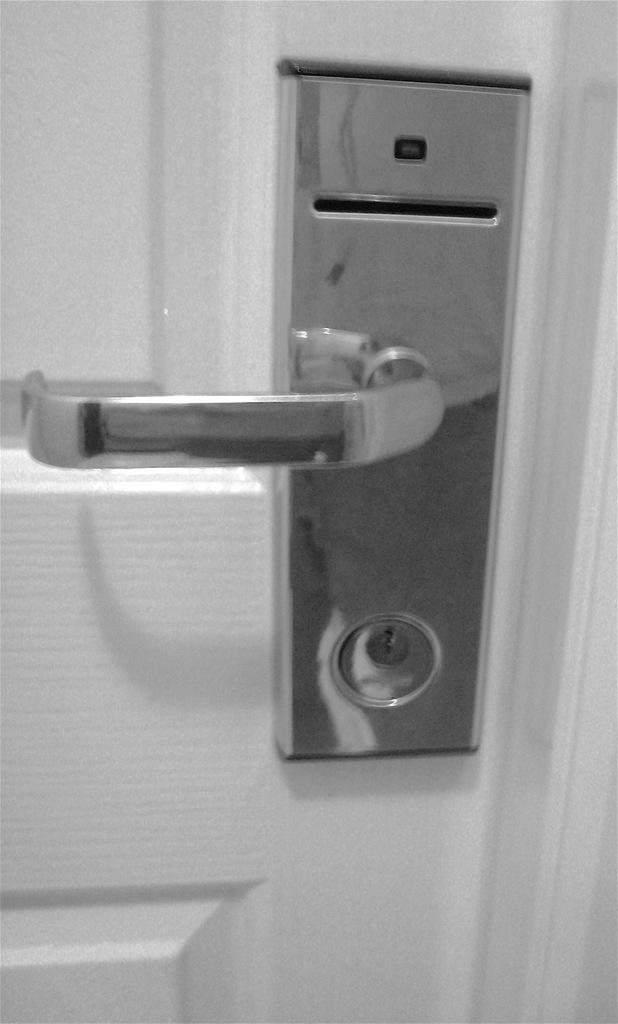What is present in the image that can be used for entering or exiting a room? There is a door in the image. What is the color of the door? The door is white in color. What material is the handle on the door made of? The handle on the door is made of metal. What type of plane can be seen flying near the door in the image? There is no plane visible in the image; it only features a door with a metal handle. 